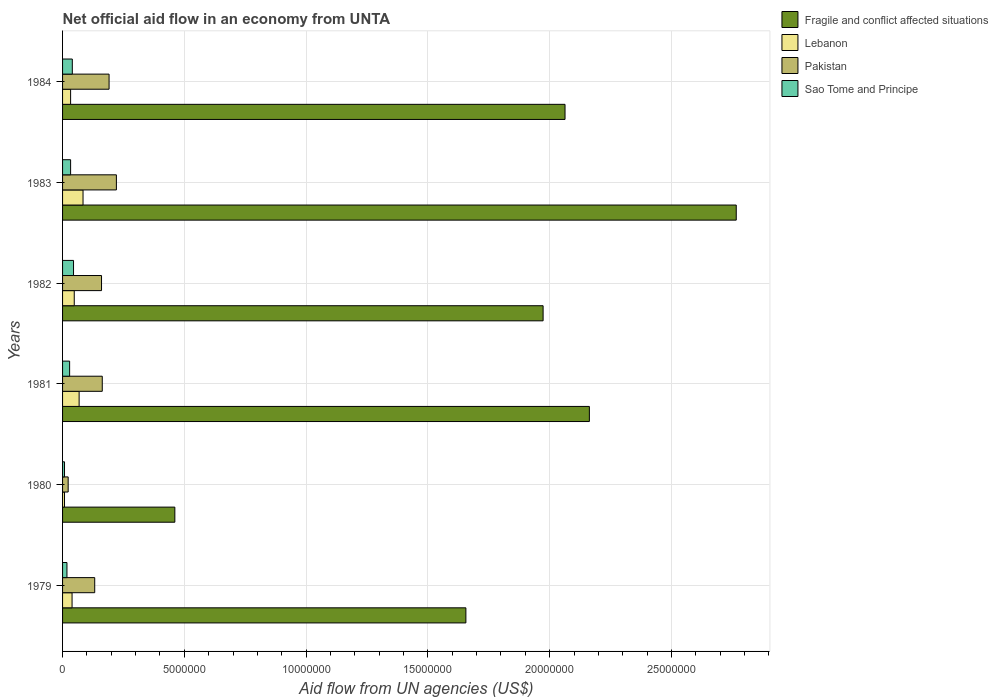How many different coloured bars are there?
Make the answer very short. 4. Are the number of bars on each tick of the Y-axis equal?
Your response must be concise. Yes. How many bars are there on the 5th tick from the bottom?
Make the answer very short. 4. In how many cases, is the number of bars for a given year not equal to the number of legend labels?
Give a very brief answer. 0. What is the net official aid flow in Fragile and conflict affected situations in 1980?
Make the answer very short. 4.61e+06. Across all years, what is the minimum net official aid flow in Lebanon?
Your response must be concise. 8.00e+04. In which year was the net official aid flow in Fragile and conflict affected situations minimum?
Ensure brevity in your answer.  1980. What is the total net official aid flow in Lebanon in the graph?
Your response must be concise. 2.80e+06. What is the difference between the net official aid flow in Fragile and conflict affected situations in 1979 and that in 1983?
Provide a succinct answer. -1.11e+07. What is the difference between the net official aid flow in Sao Tome and Principe in 1981 and the net official aid flow in Fragile and conflict affected situations in 1980?
Make the answer very short. -4.32e+06. What is the average net official aid flow in Pakistan per year?
Keep it short and to the point. 1.48e+06. In the year 1979, what is the difference between the net official aid flow in Sao Tome and Principe and net official aid flow in Pakistan?
Provide a succinct answer. -1.14e+06. In how many years, is the net official aid flow in Pakistan greater than 14000000 US$?
Give a very brief answer. 0. What is the ratio of the net official aid flow in Lebanon in 1981 to that in 1984?
Your answer should be compact. 2.06. What is the difference between the highest and the second highest net official aid flow in Sao Tome and Principe?
Give a very brief answer. 5.00e+04. What is the difference between the highest and the lowest net official aid flow in Pakistan?
Offer a terse response. 1.98e+06. Is it the case that in every year, the sum of the net official aid flow in Fragile and conflict affected situations and net official aid flow in Pakistan is greater than the sum of net official aid flow in Lebanon and net official aid flow in Sao Tome and Principe?
Provide a short and direct response. Yes. What does the 3rd bar from the top in 1983 represents?
Make the answer very short. Lebanon. What does the 1st bar from the bottom in 1979 represents?
Ensure brevity in your answer.  Fragile and conflict affected situations. How many years are there in the graph?
Provide a short and direct response. 6. Are the values on the major ticks of X-axis written in scientific E-notation?
Make the answer very short. No. Does the graph contain any zero values?
Offer a terse response. No. Does the graph contain grids?
Make the answer very short. Yes. Where does the legend appear in the graph?
Your response must be concise. Top right. How are the legend labels stacked?
Provide a succinct answer. Vertical. What is the title of the graph?
Your answer should be compact. Net official aid flow in an economy from UNTA. Does "Papua New Guinea" appear as one of the legend labels in the graph?
Give a very brief answer. No. What is the label or title of the X-axis?
Make the answer very short. Aid flow from UN agencies (US$). What is the Aid flow from UN agencies (US$) in Fragile and conflict affected situations in 1979?
Make the answer very short. 1.66e+07. What is the Aid flow from UN agencies (US$) of Lebanon in 1979?
Offer a very short reply. 3.90e+05. What is the Aid flow from UN agencies (US$) in Pakistan in 1979?
Ensure brevity in your answer.  1.32e+06. What is the Aid flow from UN agencies (US$) in Sao Tome and Principe in 1979?
Your response must be concise. 1.80e+05. What is the Aid flow from UN agencies (US$) in Fragile and conflict affected situations in 1980?
Your answer should be very brief. 4.61e+06. What is the Aid flow from UN agencies (US$) of Sao Tome and Principe in 1980?
Provide a short and direct response. 8.00e+04. What is the Aid flow from UN agencies (US$) of Fragile and conflict affected situations in 1981?
Offer a very short reply. 2.16e+07. What is the Aid flow from UN agencies (US$) in Lebanon in 1981?
Offer a very short reply. 6.80e+05. What is the Aid flow from UN agencies (US$) in Pakistan in 1981?
Provide a short and direct response. 1.63e+06. What is the Aid flow from UN agencies (US$) in Sao Tome and Principe in 1981?
Your answer should be compact. 2.90e+05. What is the Aid flow from UN agencies (US$) in Fragile and conflict affected situations in 1982?
Your answer should be compact. 1.97e+07. What is the Aid flow from UN agencies (US$) of Lebanon in 1982?
Offer a very short reply. 4.80e+05. What is the Aid flow from UN agencies (US$) of Pakistan in 1982?
Your answer should be very brief. 1.60e+06. What is the Aid flow from UN agencies (US$) of Fragile and conflict affected situations in 1983?
Give a very brief answer. 2.77e+07. What is the Aid flow from UN agencies (US$) of Lebanon in 1983?
Ensure brevity in your answer.  8.40e+05. What is the Aid flow from UN agencies (US$) in Pakistan in 1983?
Make the answer very short. 2.21e+06. What is the Aid flow from UN agencies (US$) in Sao Tome and Principe in 1983?
Your answer should be very brief. 3.30e+05. What is the Aid flow from UN agencies (US$) in Fragile and conflict affected situations in 1984?
Offer a very short reply. 2.06e+07. What is the Aid flow from UN agencies (US$) of Lebanon in 1984?
Your response must be concise. 3.30e+05. What is the Aid flow from UN agencies (US$) of Pakistan in 1984?
Give a very brief answer. 1.91e+06. What is the Aid flow from UN agencies (US$) in Sao Tome and Principe in 1984?
Offer a very short reply. 4.00e+05. Across all years, what is the maximum Aid flow from UN agencies (US$) of Fragile and conflict affected situations?
Provide a short and direct response. 2.77e+07. Across all years, what is the maximum Aid flow from UN agencies (US$) of Lebanon?
Provide a short and direct response. 8.40e+05. Across all years, what is the maximum Aid flow from UN agencies (US$) of Pakistan?
Offer a terse response. 2.21e+06. Across all years, what is the maximum Aid flow from UN agencies (US$) in Sao Tome and Principe?
Provide a short and direct response. 4.50e+05. Across all years, what is the minimum Aid flow from UN agencies (US$) in Fragile and conflict affected situations?
Offer a terse response. 4.61e+06. Across all years, what is the minimum Aid flow from UN agencies (US$) of Pakistan?
Offer a very short reply. 2.30e+05. What is the total Aid flow from UN agencies (US$) of Fragile and conflict affected situations in the graph?
Your response must be concise. 1.11e+08. What is the total Aid flow from UN agencies (US$) in Lebanon in the graph?
Ensure brevity in your answer.  2.80e+06. What is the total Aid flow from UN agencies (US$) in Pakistan in the graph?
Offer a terse response. 8.90e+06. What is the total Aid flow from UN agencies (US$) of Sao Tome and Principe in the graph?
Offer a very short reply. 1.73e+06. What is the difference between the Aid flow from UN agencies (US$) in Fragile and conflict affected situations in 1979 and that in 1980?
Ensure brevity in your answer.  1.20e+07. What is the difference between the Aid flow from UN agencies (US$) in Pakistan in 1979 and that in 1980?
Provide a short and direct response. 1.09e+06. What is the difference between the Aid flow from UN agencies (US$) of Fragile and conflict affected situations in 1979 and that in 1981?
Your answer should be compact. -5.07e+06. What is the difference between the Aid flow from UN agencies (US$) of Pakistan in 1979 and that in 1981?
Offer a terse response. -3.10e+05. What is the difference between the Aid flow from UN agencies (US$) of Fragile and conflict affected situations in 1979 and that in 1982?
Provide a succinct answer. -3.17e+06. What is the difference between the Aid flow from UN agencies (US$) of Pakistan in 1979 and that in 1982?
Provide a succinct answer. -2.80e+05. What is the difference between the Aid flow from UN agencies (US$) in Sao Tome and Principe in 1979 and that in 1982?
Your answer should be very brief. -2.70e+05. What is the difference between the Aid flow from UN agencies (US$) in Fragile and conflict affected situations in 1979 and that in 1983?
Provide a short and direct response. -1.11e+07. What is the difference between the Aid flow from UN agencies (US$) in Lebanon in 1979 and that in 1983?
Your response must be concise. -4.50e+05. What is the difference between the Aid flow from UN agencies (US$) in Pakistan in 1979 and that in 1983?
Your answer should be compact. -8.90e+05. What is the difference between the Aid flow from UN agencies (US$) of Fragile and conflict affected situations in 1979 and that in 1984?
Give a very brief answer. -4.07e+06. What is the difference between the Aid flow from UN agencies (US$) in Lebanon in 1979 and that in 1984?
Offer a very short reply. 6.00e+04. What is the difference between the Aid flow from UN agencies (US$) of Pakistan in 1979 and that in 1984?
Make the answer very short. -5.90e+05. What is the difference between the Aid flow from UN agencies (US$) of Fragile and conflict affected situations in 1980 and that in 1981?
Provide a short and direct response. -1.70e+07. What is the difference between the Aid flow from UN agencies (US$) in Lebanon in 1980 and that in 1981?
Give a very brief answer. -6.00e+05. What is the difference between the Aid flow from UN agencies (US$) in Pakistan in 1980 and that in 1981?
Offer a very short reply. -1.40e+06. What is the difference between the Aid flow from UN agencies (US$) in Fragile and conflict affected situations in 1980 and that in 1982?
Offer a very short reply. -1.51e+07. What is the difference between the Aid flow from UN agencies (US$) of Lebanon in 1980 and that in 1982?
Your answer should be compact. -4.00e+05. What is the difference between the Aid flow from UN agencies (US$) of Pakistan in 1980 and that in 1982?
Ensure brevity in your answer.  -1.37e+06. What is the difference between the Aid flow from UN agencies (US$) in Sao Tome and Principe in 1980 and that in 1982?
Your answer should be compact. -3.70e+05. What is the difference between the Aid flow from UN agencies (US$) of Fragile and conflict affected situations in 1980 and that in 1983?
Your answer should be very brief. -2.30e+07. What is the difference between the Aid flow from UN agencies (US$) in Lebanon in 1980 and that in 1983?
Offer a very short reply. -7.60e+05. What is the difference between the Aid flow from UN agencies (US$) in Pakistan in 1980 and that in 1983?
Keep it short and to the point. -1.98e+06. What is the difference between the Aid flow from UN agencies (US$) in Fragile and conflict affected situations in 1980 and that in 1984?
Provide a short and direct response. -1.60e+07. What is the difference between the Aid flow from UN agencies (US$) in Lebanon in 1980 and that in 1984?
Make the answer very short. -2.50e+05. What is the difference between the Aid flow from UN agencies (US$) in Pakistan in 1980 and that in 1984?
Provide a succinct answer. -1.68e+06. What is the difference between the Aid flow from UN agencies (US$) of Sao Tome and Principe in 1980 and that in 1984?
Offer a very short reply. -3.20e+05. What is the difference between the Aid flow from UN agencies (US$) of Fragile and conflict affected situations in 1981 and that in 1982?
Keep it short and to the point. 1.90e+06. What is the difference between the Aid flow from UN agencies (US$) in Pakistan in 1981 and that in 1982?
Offer a very short reply. 3.00e+04. What is the difference between the Aid flow from UN agencies (US$) of Sao Tome and Principe in 1981 and that in 1982?
Your response must be concise. -1.60e+05. What is the difference between the Aid flow from UN agencies (US$) of Fragile and conflict affected situations in 1981 and that in 1983?
Give a very brief answer. -6.03e+06. What is the difference between the Aid flow from UN agencies (US$) in Pakistan in 1981 and that in 1983?
Your answer should be compact. -5.80e+05. What is the difference between the Aid flow from UN agencies (US$) in Sao Tome and Principe in 1981 and that in 1983?
Your response must be concise. -4.00e+04. What is the difference between the Aid flow from UN agencies (US$) of Fragile and conflict affected situations in 1981 and that in 1984?
Your response must be concise. 1.00e+06. What is the difference between the Aid flow from UN agencies (US$) of Lebanon in 1981 and that in 1984?
Your answer should be very brief. 3.50e+05. What is the difference between the Aid flow from UN agencies (US$) of Pakistan in 1981 and that in 1984?
Offer a terse response. -2.80e+05. What is the difference between the Aid flow from UN agencies (US$) of Fragile and conflict affected situations in 1982 and that in 1983?
Provide a short and direct response. -7.93e+06. What is the difference between the Aid flow from UN agencies (US$) of Lebanon in 1982 and that in 1983?
Provide a short and direct response. -3.60e+05. What is the difference between the Aid flow from UN agencies (US$) in Pakistan in 1982 and that in 1983?
Offer a very short reply. -6.10e+05. What is the difference between the Aid flow from UN agencies (US$) in Sao Tome and Principe in 1982 and that in 1983?
Provide a succinct answer. 1.20e+05. What is the difference between the Aid flow from UN agencies (US$) in Fragile and conflict affected situations in 1982 and that in 1984?
Your answer should be very brief. -9.00e+05. What is the difference between the Aid flow from UN agencies (US$) in Pakistan in 1982 and that in 1984?
Your answer should be compact. -3.10e+05. What is the difference between the Aid flow from UN agencies (US$) in Fragile and conflict affected situations in 1983 and that in 1984?
Your response must be concise. 7.03e+06. What is the difference between the Aid flow from UN agencies (US$) in Lebanon in 1983 and that in 1984?
Your response must be concise. 5.10e+05. What is the difference between the Aid flow from UN agencies (US$) in Fragile and conflict affected situations in 1979 and the Aid flow from UN agencies (US$) in Lebanon in 1980?
Your response must be concise. 1.65e+07. What is the difference between the Aid flow from UN agencies (US$) in Fragile and conflict affected situations in 1979 and the Aid flow from UN agencies (US$) in Pakistan in 1980?
Offer a terse response. 1.63e+07. What is the difference between the Aid flow from UN agencies (US$) in Fragile and conflict affected situations in 1979 and the Aid flow from UN agencies (US$) in Sao Tome and Principe in 1980?
Ensure brevity in your answer.  1.65e+07. What is the difference between the Aid flow from UN agencies (US$) of Lebanon in 1979 and the Aid flow from UN agencies (US$) of Pakistan in 1980?
Ensure brevity in your answer.  1.60e+05. What is the difference between the Aid flow from UN agencies (US$) of Lebanon in 1979 and the Aid flow from UN agencies (US$) of Sao Tome and Principe in 1980?
Make the answer very short. 3.10e+05. What is the difference between the Aid flow from UN agencies (US$) in Pakistan in 1979 and the Aid flow from UN agencies (US$) in Sao Tome and Principe in 1980?
Provide a succinct answer. 1.24e+06. What is the difference between the Aid flow from UN agencies (US$) of Fragile and conflict affected situations in 1979 and the Aid flow from UN agencies (US$) of Lebanon in 1981?
Offer a terse response. 1.59e+07. What is the difference between the Aid flow from UN agencies (US$) in Fragile and conflict affected situations in 1979 and the Aid flow from UN agencies (US$) in Pakistan in 1981?
Ensure brevity in your answer.  1.49e+07. What is the difference between the Aid flow from UN agencies (US$) in Fragile and conflict affected situations in 1979 and the Aid flow from UN agencies (US$) in Sao Tome and Principe in 1981?
Keep it short and to the point. 1.63e+07. What is the difference between the Aid flow from UN agencies (US$) in Lebanon in 1979 and the Aid flow from UN agencies (US$) in Pakistan in 1981?
Make the answer very short. -1.24e+06. What is the difference between the Aid flow from UN agencies (US$) of Pakistan in 1979 and the Aid flow from UN agencies (US$) of Sao Tome and Principe in 1981?
Provide a short and direct response. 1.03e+06. What is the difference between the Aid flow from UN agencies (US$) in Fragile and conflict affected situations in 1979 and the Aid flow from UN agencies (US$) in Lebanon in 1982?
Offer a terse response. 1.61e+07. What is the difference between the Aid flow from UN agencies (US$) in Fragile and conflict affected situations in 1979 and the Aid flow from UN agencies (US$) in Pakistan in 1982?
Offer a terse response. 1.50e+07. What is the difference between the Aid flow from UN agencies (US$) of Fragile and conflict affected situations in 1979 and the Aid flow from UN agencies (US$) of Sao Tome and Principe in 1982?
Your answer should be very brief. 1.61e+07. What is the difference between the Aid flow from UN agencies (US$) of Lebanon in 1979 and the Aid flow from UN agencies (US$) of Pakistan in 1982?
Your answer should be compact. -1.21e+06. What is the difference between the Aid flow from UN agencies (US$) in Lebanon in 1979 and the Aid flow from UN agencies (US$) in Sao Tome and Principe in 1982?
Ensure brevity in your answer.  -6.00e+04. What is the difference between the Aid flow from UN agencies (US$) in Pakistan in 1979 and the Aid flow from UN agencies (US$) in Sao Tome and Principe in 1982?
Ensure brevity in your answer.  8.70e+05. What is the difference between the Aid flow from UN agencies (US$) of Fragile and conflict affected situations in 1979 and the Aid flow from UN agencies (US$) of Lebanon in 1983?
Your answer should be compact. 1.57e+07. What is the difference between the Aid flow from UN agencies (US$) in Fragile and conflict affected situations in 1979 and the Aid flow from UN agencies (US$) in Pakistan in 1983?
Make the answer very short. 1.44e+07. What is the difference between the Aid flow from UN agencies (US$) of Fragile and conflict affected situations in 1979 and the Aid flow from UN agencies (US$) of Sao Tome and Principe in 1983?
Provide a short and direct response. 1.62e+07. What is the difference between the Aid flow from UN agencies (US$) in Lebanon in 1979 and the Aid flow from UN agencies (US$) in Pakistan in 1983?
Your answer should be compact. -1.82e+06. What is the difference between the Aid flow from UN agencies (US$) of Pakistan in 1979 and the Aid flow from UN agencies (US$) of Sao Tome and Principe in 1983?
Your response must be concise. 9.90e+05. What is the difference between the Aid flow from UN agencies (US$) in Fragile and conflict affected situations in 1979 and the Aid flow from UN agencies (US$) in Lebanon in 1984?
Provide a succinct answer. 1.62e+07. What is the difference between the Aid flow from UN agencies (US$) of Fragile and conflict affected situations in 1979 and the Aid flow from UN agencies (US$) of Pakistan in 1984?
Give a very brief answer. 1.46e+07. What is the difference between the Aid flow from UN agencies (US$) in Fragile and conflict affected situations in 1979 and the Aid flow from UN agencies (US$) in Sao Tome and Principe in 1984?
Your response must be concise. 1.62e+07. What is the difference between the Aid flow from UN agencies (US$) of Lebanon in 1979 and the Aid flow from UN agencies (US$) of Pakistan in 1984?
Make the answer very short. -1.52e+06. What is the difference between the Aid flow from UN agencies (US$) in Pakistan in 1979 and the Aid flow from UN agencies (US$) in Sao Tome and Principe in 1984?
Make the answer very short. 9.20e+05. What is the difference between the Aid flow from UN agencies (US$) in Fragile and conflict affected situations in 1980 and the Aid flow from UN agencies (US$) in Lebanon in 1981?
Make the answer very short. 3.93e+06. What is the difference between the Aid flow from UN agencies (US$) of Fragile and conflict affected situations in 1980 and the Aid flow from UN agencies (US$) of Pakistan in 1981?
Make the answer very short. 2.98e+06. What is the difference between the Aid flow from UN agencies (US$) in Fragile and conflict affected situations in 1980 and the Aid flow from UN agencies (US$) in Sao Tome and Principe in 1981?
Give a very brief answer. 4.32e+06. What is the difference between the Aid flow from UN agencies (US$) of Lebanon in 1980 and the Aid flow from UN agencies (US$) of Pakistan in 1981?
Your response must be concise. -1.55e+06. What is the difference between the Aid flow from UN agencies (US$) of Lebanon in 1980 and the Aid flow from UN agencies (US$) of Sao Tome and Principe in 1981?
Provide a succinct answer. -2.10e+05. What is the difference between the Aid flow from UN agencies (US$) of Fragile and conflict affected situations in 1980 and the Aid flow from UN agencies (US$) of Lebanon in 1982?
Keep it short and to the point. 4.13e+06. What is the difference between the Aid flow from UN agencies (US$) of Fragile and conflict affected situations in 1980 and the Aid flow from UN agencies (US$) of Pakistan in 1982?
Ensure brevity in your answer.  3.01e+06. What is the difference between the Aid flow from UN agencies (US$) of Fragile and conflict affected situations in 1980 and the Aid flow from UN agencies (US$) of Sao Tome and Principe in 1982?
Your answer should be very brief. 4.16e+06. What is the difference between the Aid flow from UN agencies (US$) in Lebanon in 1980 and the Aid flow from UN agencies (US$) in Pakistan in 1982?
Keep it short and to the point. -1.52e+06. What is the difference between the Aid flow from UN agencies (US$) in Lebanon in 1980 and the Aid flow from UN agencies (US$) in Sao Tome and Principe in 1982?
Your answer should be compact. -3.70e+05. What is the difference between the Aid flow from UN agencies (US$) in Pakistan in 1980 and the Aid flow from UN agencies (US$) in Sao Tome and Principe in 1982?
Provide a short and direct response. -2.20e+05. What is the difference between the Aid flow from UN agencies (US$) in Fragile and conflict affected situations in 1980 and the Aid flow from UN agencies (US$) in Lebanon in 1983?
Ensure brevity in your answer.  3.77e+06. What is the difference between the Aid flow from UN agencies (US$) in Fragile and conflict affected situations in 1980 and the Aid flow from UN agencies (US$) in Pakistan in 1983?
Your answer should be compact. 2.40e+06. What is the difference between the Aid flow from UN agencies (US$) of Fragile and conflict affected situations in 1980 and the Aid flow from UN agencies (US$) of Sao Tome and Principe in 1983?
Give a very brief answer. 4.28e+06. What is the difference between the Aid flow from UN agencies (US$) of Lebanon in 1980 and the Aid flow from UN agencies (US$) of Pakistan in 1983?
Your response must be concise. -2.13e+06. What is the difference between the Aid flow from UN agencies (US$) of Pakistan in 1980 and the Aid flow from UN agencies (US$) of Sao Tome and Principe in 1983?
Provide a succinct answer. -1.00e+05. What is the difference between the Aid flow from UN agencies (US$) of Fragile and conflict affected situations in 1980 and the Aid flow from UN agencies (US$) of Lebanon in 1984?
Give a very brief answer. 4.28e+06. What is the difference between the Aid flow from UN agencies (US$) of Fragile and conflict affected situations in 1980 and the Aid flow from UN agencies (US$) of Pakistan in 1984?
Provide a short and direct response. 2.70e+06. What is the difference between the Aid flow from UN agencies (US$) of Fragile and conflict affected situations in 1980 and the Aid flow from UN agencies (US$) of Sao Tome and Principe in 1984?
Your response must be concise. 4.21e+06. What is the difference between the Aid flow from UN agencies (US$) of Lebanon in 1980 and the Aid flow from UN agencies (US$) of Pakistan in 1984?
Ensure brevity in your answer.  -1.83e+06. What is the difference between the Aid flow from UN agencies (US$) of Lebanon in 1980 and the Aid flow from UN agencies (US$) of Sao Tome and Principe in 1984?
Keep it short and to the point. -3.20e+05. What is the difference between the Aid flow from UN agencies (US$) of Pakistan in 1980 and the Aid flow from UN agencies (US$) of Sao Tome and Principe in 1984?
Your response must be concise. -1.70e+05. What is the difference between the Aid flow from UN agencies (US$) of Fragile and conflict affected situations in 1981 and the Aid flow from UN agencies (US$) of Lebanon in 1982?
Your response must be concise. 2.12e+07. What is the difference between the Aid flow from UN agencies (US$) in Fragile and conflict affected situations in 1981 and the Aid flow from UN agencies (US$) in Pakistan in 1982?
Provide a succinct answer. 2.00e+07. What is the difference between the Aid flow from UN agencies (US$) of Fragile and conflict affected situations in 1981 and the Aid flow from UN agencies (US$) of Sao Tome and Principe in 1982?
Provide a succinct answer. 2.12e+07. What is the difference between the Aid flow from UN agencies (US$) of Lebanon in 1981 and the Aid flow from UN agencies (US$) of Pakistan in 1982?
Ensure brevity in your answer.  -9.20e+05. What is the difference between the Aid flow from UN agencies (US$) of Lebanon in 1981 and the Aid flow from UN agencies (US$) of Sao Tome and Principe in 1982?
Offer a very short reply. 2.30e+05. What is the difference between the Aid flow from UN agencies (US$) of Pakistan in 1981 and the Aid flow from UN agencies (US$) of Sao Tome and Principe in 1982?
Keep it short and to the point. 1.18e+06. What is the difference between the Aid flow from UN agencies (US$) of Fragile and conflict affected situations in 1981 and the Aid flow from UN agencies (US$) of Lebanon in 1983?
Provide a short and direct response. 2.08e+07. What is the difference between the Aid flow from UN agencies (US$) in Fragile and conflict affected situations in 1981 and the Aid flow from UN agencies (US$) in Pakistan in 1983?
Your answer should be very brief. 1.94e+07. What is the difference between the Aid flow from UN agencies (US$) in Fragile and conflict affected situations in 1981 and the Aid flow from UN agencies (US$) in Sao Tome and Principe in 1983?
Offer a very short reply. 2.13e+07. What is the difference between the Aid flow from UN agencies (US$) of Lebanon in 1981 and the Aid flow from UN agencies (US$) of Pakistan in 1983?
Provide a short and direct response. -1.53e+06. What is the difference between the Aid flow from UN agencies (US$) in Pakistan in 1981 and the Aid flow from UN agencies (US$) in Sao Tome and Principe in 1983?
Your answer should be very brief. 1.30e+06. What is the difference between the Aid flow from UN agencies (US$) in Fragile and conflict affected situations in 1981 and the Aid flow from UN agencies (US$) in Lebanon in 1984?
Ensure brevity in your answer.  2.13e+07. What is the difference between the Aid flow from UN agencies (US$) of Fragile and conflict affected situations in 1981 and the Aid flow from UN agencies (US$) of Pakistan in 1984?
Your answer should be very brief. 1.97e+07. What is the difference between the Aid flow from UN agencies (US$) of Fragile and conflict affected situations in 1981 and the Aid flow from UN agencies (US$) of Sao Tome and Principe in 1984?
Keep it short and to the point. 2.12e+07. What is the difference between the Aid flow from UN agencies (US$) of Lebanon in 1981 and the Aid flow from UN agencies (US$) of Pakistan in 1984?
Ensure brevity in your answer.  -1.23e+06. What is the difference between the Aid flow from UN agencies (US$) in Lebanon in 1981 and the Aid flow from UN agencies (US$) in Sao Tome and Principe in 1984?
Provide a short and direct response. 2.80e+05. What is the difference between the Aid flow from UN agencies (US$) of Pakistan in 1981 and the Aid flow from UN agencies (US$) of Sao Tome and Principe in 1984?
Your answer should be compact. 1.23e+06. What is the difference between the Aid flow from UN agencies (US$) in Fragile and conflict affected situations in 1982 and the Aid flow from UN agencies (US$) in Lebanon in 1983?
Make the answer very short. 1.89e+07. What is the difference between the Aid flow from UN agencies (US$) in Fragile and conflict affected situations in 1982 and the Aid flow from UN agencies (US$) in Pakistan in 1983?
Offer a very short reply. 1.75e+07. What is the difference between the Aid flow from UN agencies (US$) in Fragile and conflict affected situations in 1982 and the Aid flow from UN agencies (US$) in Sao Tome and Principe in 1983?
Your answer should be compact. 1.94e+07. What is the difference between the Aid flow from UN agencies (US$) in Lebanon in 1982 and the Aid flow from UN agencies (US$) in Pakistan in 1983?
Your response must be concise. -1.73e+06. What is the difference between the Aid flow from UN agencies (US$) of Lebanon in 1982 and the Aid flow from UN agencies (US$) of Sao Tome and Principe in 1983?
Give a very brief answer. 1.50e+05. What is the difference between the Aid flow from UN agencies (US$) in Pakistan in 1982 and the Aid flow from UN agencies (US$) in Sao Tome and Principe in 1983?
Offer a very short reply. 1.27e+06. What is the difference between the Aid flow from UN agencies (US$) in Fragile and conflict affected situations in 1982 and the Aid flow from UN agencies (US$) in Lebanon in 1984?
Provide a short and direct response. 1.94e+07. What is the difference between the Aid flow from UN agencies (US$) in Fragile and conflict affected situations in 1982 and the Aid flow from UN agencies (US$) in Pakistan in 1984?
Your answer should be compact. 1.78e+07. What is the difference between the Aid flow from UN agencies (US$) of Fragile and conflict affected situations in 1982 and the Aid flow from UN agencies (US$) of Sao Tome and Principe in 1984?
Your response must be concise. 1.93e+07. What is the difference between the Aid flow from UN agencies (US$) of Lebanon in 1982 and the Aid flow from UN agencies (US$) of Pakistan in 1984?
Your answer should be very brief. -1.43e+06. What is the difference between the Aid flow from UN agencies (US$) of Pakistan in 1982 and the Aid flow from UN agencies (US$) of Sao Tome and Principe in 1984?
Make the answer very short. 1.20e+06. What is the difference between the Aid flow from UN agencies (US$) of Fragile and conflict affected situations in 1983 and the Aid flow from UN agencies (US$) of Lebanon in 1984?
Your response must be concise. 2.73e+07. What is the difference between the Aid flow from UN agencies (US$) of Fragile and conflict affected situations in 1983 and the Aid flow from UN agencies (US$) of Pakistan in 1984?
Your answer should be very brief. 2.58e+07. What is the difference between the Aid flow from UN agencies (US$) of Fragile and conflict affected situations in 1983 and the Aid flow from UN agencies (US$) of Sao Tome and Principe in 1984?
Ensure brevity in your answer.  2.73e+07. What is the difference between the Aid flow from UN agencies (US$) of Lebanon in 1983 and the Aid flow from UN agencies (US$) of Pakistan in 1984?
Your answer should be compact. -1.07e+06. What is the difference between the Aid flow from UN agencies (US$) of Pakistan in 1983 and the Aid flow from UN agencies (US$) of Sao Tome and Principe in 1984?
Provide a short and direct response. 1.81e+06. What is the average Aid flow from UN agencies (US$) in Fragile and conflict affected situations per year?
Your answer should be very brief. 1.85e+07. What is the average Aid flow from UN agencies (US$) of Lebanon per year?
Keep it short and to the point. 4.67e+05. What is the average Aid flow from UN agencies (US$) in Pakistan per year?
Give a very brief answer. 1.48e+06. What is the average Aid flow from UN agencies (US$) of Sao Tome and Principe per year?
Keep it short and to the point. 2.88e+05. In the year 1979, what is the difference between the Aid flow from UN agencies (US$) in Fragile and conflict affected situations and Aid flow from UN agencies (US$) in Lebanon?
Give a very brief answer. 1.62e+07. In the year 1979, what is the difference between the Aid flow from UN agencies (US$) of Fragile and conflict affected situations and Aid flow from UN agencies (US$) of Pakistan?
Offer a very short reply. 1.52e+07. In the year 1979, what is the difference between the Aid flow from UN agencies (US$) in Fragile and conflict affected situations and Aid flow from UN agencies (US$) in Sao Tome and Principe?
Your response must be concise. 1.64e+07. In the year 1979, what is the difference between the Aid flow from UN agencies (US$) of Lebanon and Aid flow from UN agencies (US$) of Pakistan?
Provide a succinct answer. -9.30e+05. In the year 1979, what is the difference between the Aid flow from UN agencies (US$) of Pakistan and Aid flow from UN agencies (US$) of Sao Tome and Principe?
Ensure brevity in your answer.  1.14e+06. In the year 1980, what is the difference between the Aid flow from UN agencies (US$) in Fragile and conflict affected situations and Aid flow from UN agencies (US$) in Lebanon?
Your answer should be very brief. 4.53e+06. In the year 1980, what is the difference between the Aid flow from UN agencies (US$) of Fragile and conflict affected situations and Aid flow from UN agencies (US$) of Pakistan?
Offer a very short reply. 4.38e+06. In the year 1980, what is the difference between the Aid flow from UN agencies (US$) in Fragile and conflict affected situations and Aid flow from UN agencies (US$) in Sao Tome and Principe?
Your answer should be very brief. 4.53e+06. In the year 1980, what is the difference between the Aid flow from UN agencies (US$) of Lebanon and Aid flow from UN agencies (US$) of Pakistan?
Offer a terse response. -1.50e+05. In the year 1980, what is the difference between the Aid flow from UN agencies (US$) of Lebanon and Aid flow from UN agencies (US$) of Sao Tome and Principe?
Your answer should be compact. 0. In the year 1980, what is the difference between the Aid flow from UN agencies (US$) of Pakistan and Aid flow from UN agencies (US$) of Sao Tome and Principe?
Offer a very short reply. 1.50e+05. In the year 1981, what is the difference between the Aid flow from UN agencies (US$) in Fragile and conflict affected situations and Aid flow from UN agencies (US$) in Lebanon?
Offer a very short reply. 2.10e+07. In the year 1981, what is the difference between the Aid flow from UN agencies (US$) in Fragile and conflict affected situations and Aid flow from UN agencies (US$) in Sao Tome and Principe?
Make the answer very short. 2.13e+07. In the year 1981, what is the difference between the Aid flow from UN agencies (US$) in Lebanon and Aid flow from UN agencies (US$) in Pakistan?
Offer a very short reply. -9.50e+05. In the year 1981, what is the difference between the Aid flow from UN agencies (US$) of Lebanon and Aid flow from UN agencies (US$) of Sao Tome and Principe?
Your answer should be compact. 3.90e+05. In the year 1981, what is the difference between the Aid flow from UN agencies (US$) of Pakistan and Aid flow from UN agencies (US$) of Sao Tome and Principe?
Your answer should be very brief. 1.34e+06. In the year 1982, what is the difference between the Aid flow from UN agencies (US$) in Fragile and conflict affected situations and Aid flow from UN agencies (US$) in Lebanon?
Make the answer very short. 1.92e+07. In the year 1982, what is the difference between the Aid flow from UN agencies (US$) of Fragile and conflict affected situations and Aid flow from UN agencies (US$) of Pakistan?
Give a very brief answer. 1.81e+07. In the year 1982, what is the difference between the Aid flow from UN agencies (US$) of Fragile and conflict affected situations and Aid flow from UN agencies (US$) of Sao Tome and Principe?
Provide a succinct answer. 1.93e+07. In the year 1982, what is the difference between the Aid flow from UN agencies (US$) in Lebanon and Aid flow from UN agencies (US$) in Pakistan?
Your answer should be compact. -1.12e+06. In the year 1982, what is the difference between the Aid flow from UN agencies (US$) of Lebanon and Aid flow from UN agencies (US$) of Sao Tome and Principe?
Give a very brief answer. 3.00e+04. In the year 1982, what is the difference between the Aid flow from UN agencies (US$) in Pakistan and Aid flow from UN agencies (US$) in Sao Tome and Principe?
Provide a short and direct response. 1.15e+06. In the year 1983, what is the difference between the Aid flow from UN agencies (US$) of Fragile and conflict affected situations and Aid flow from UN agencies (US$) of Lebanon?
Your answer should be very brief. 2.68e+07. In the year 1983, what is the difference between the Aid flow from UN agencies (US$) in Fragile and conflict affected situations and Aid flow from UN agencies (US$) in Pakistan?
Ensure brevity in your answer.  2.54e+07. In the year 1983, what is the difference between the Aid flow from UN agencies (US$) in Fragile and conflict affected situations and Aid flow from UN agencies (US$) in Sao Tome and Principe?
Your answer should be compact. 2.73e+07. In the year 1983, what is the difference between the Aid flow from UN agencies (US$) of Lebanon and Aid flow from UN agencies (US$) of Pakistan?
Your response must be concise. -1.37e+06. In the year 1983, what is the difference between the Aid flow from UN agencies (US$) of Lebanon and Aid flow from UN agencies (US$) of Sao Tome and Principe?
Your response must be concise. 5.10e+05. In the year 1983, what is the difference between the Aid flow from UN agencies (US$) in Pakistan and Aid flow from UN agencies (US$) in Sao Tome and Principe?
Your answer should be compact. 1.88e+06. In the year 1984, what is the difference between the Aid flow from UN agencies (US$) of Fragile and conflict affected situations and Aid flow from UN agencies (US$) of Lebanon?
Your response must be concise. 2.03e+07. In the year 1984, what is the difference between the Aid flow from UN agencies (US$) of Fragile and conflict affected situations and Aid flow from UN agencies (US$) of Pakistan?
Offer a very short reply. 1.87e+07. In the year 1984, what is the difference between the Aid flow from UN agencies (US$) in Fragile and conflict affected situations and Aid flow from UN agencies (US$) in Sao Tome and Principe?
Your answer should be very brief. 2.02e+07. In the year 1984, what is the difference between the Aid flow from UN agencies (US$) in Lebanon and Aid flow from UN agencies (US$) in Pakistan?
Provide a succinct answer. -1.58e+06. In the year 1984, what is the difference between the Aid flow from UN agencies (US$) of Lebanon and Aid flow from UN agencies (US$) of Sao Tome and Principe?
Offer a very short reply. -7.00e+04. In the year 1984, what is the difference between the Aid flow from UN agencies (US$) of Pakistan and Aid flow from UN agencies (US$) of Sao Tome and Principe?
Your answer should be very brief. 1.51e+06. What is the ratio of the Aid flow from UN agencies (US$) in Fragile and conflict affected situations in 1979 to that in 1980?
Provide a short and direct response. 3.59. What is the ratio of the Aid flow from UN agencies (US$) of Lebanon in 1979 to that in 1980?
Ensure brevity in your answer.  4.88. What is the ratio of the Aid flow from UN agencies (US$) in Pakistan in 1979 to that in 1980?
Your answer should be very brief. 5.74. What is the ratio of the Aid flow from UN agencies (US$) in Sao Tome and Principe in 1979 to that in 1980?
Keep it short and to the point. 2.25. What is the ratio of the Aid flow from UN agencies (US$) in Fragile and conflict affected situations in 1979 to that in 1981?
Provide a succinct answer. 0.77. What is the ratio of the Aid flow from UN agencies (US$) of Lebanon in 1979 to that in 1981?
Offer a very short reply. 0.57. What is the ratio of the Aid flow from UN agencies (US$) in Pakistan in 1979 to that in 1981?
Make the answer very short. 0.81. What is the ratio of the Aid flow from UN agencies (US$) in Sao Tome and Principe in 1979 to that in 1981?
Keep it short and to the point. 0.62. What is the ratio of the Aid flow from UN agencies (US$) of Fragile and conflict affected situations in 1979 to that in 1982?
Your response must be concise. 0.84. What is the ratio of the Aid flow from UN agencies (US$) in Lebanon in 1979 to that in 1982?
Provide a succinct answer. 0.81. What is the ratio of the Aid flow from UN agencies (US$) of Pakistan in 1979 to that in 1982?
Provide a succinct answer. 0.82. What is the ratio of the Aid flow from UN agencies (US$) of Fragile and conflict affected situations in 1979 to that in 1983?
Provide a succinct answer. 0.6. What is the ratio of the Aid flow from UN agencies (US$) of Lebanon in 1979 to that in 1983?
Give a very brief answer. 0.46. What is the ratio of the Aid flow from UN agencies (US$) of Pakistan in 1979 to that in 1983?
Your answer should be very brief. 0.6. What is the ratio of the Aid flow from UN agencies (US$) in Sao Tome and Principe in 1979 to that in 1983?
Ensure brevity in your answer.  0.55. What is the ratio of the Aid flow from UN agencies (US$) of Fragile and conflict affected situations in 1979 to that in 1984?
Make the answer very short. 0.8. What is the ratio of the Aid flow from UN agencies (US$) of Lebanon in 1979 to that in 1984?
Keep it short and to the point. 1.18. What is the ratio of the Aid flow from UN agencies (US$) of Pakistan in 1979 to that in 1984?
Your answer should be very brief. 0.69. What is the ratio of the Aid flow from UN agencies (US$) in Sao Tome and Principe in 1979 to that in 1984?
Provide a short and direct response. 0.45. What is the ratio of the Aid flow from UN agencies (US$) in Fragile and conflict affected situations in 1980 to that in 1981?
Your answer should be very brief. 0.21. What is the ratio of the Aid flow from UN agencies (US$) of Lebanon in 1980 to that in 1981?
Offer a very short reply. 0.12. What is the ratio of the Aid flow from UN agencies (US$) in Pakistan in 1980 to that in 1981?
Ensure brevity in your answer.  0.14. What is the ratio of the Aid flow from UN agencies (US$) of Sao Tome and Principe in 1980 to that in 1981?
Make the answer very short. 0.28. What is the ratio of the Aid flow from UN agencies (US$) in Fragile and conflict affected situations in 1980 to that in 1982?
Your answer should be very brief. 0.23. What is the ratio of the Aid flow from UN agencies (US$) in Lebanon in 1980 to that in 1982?
Provide a short and direct response. 0.17. What is the ratio of the Aid flow from UN agencies (US$) in Pakistan in 1980 to that in 1982?
Provide a short and direct response. 0.14. What is the ratio of the Aid flow from UN agencies (US$) of Sao Tome and Principe in 1980 to that in 1982?
Offer a very short reply. 0.18. What is the ratio of the Aid flow from UN agencies (US$) of Fragile and conflict affected situations in 1980 to that in 1983?
Offer a terse response. 0.17. What is the ratio of the Aid flow from UN agencies (US$) in Lebanon in 1980 to that in 1983?
Your response must be concise. 0.1. What is the ratio of the Aid flow from UN agencies (US$) in Pakistan in 1980 to that in 1983?
Give a very brief answer. 0.1. What is the ratio of the Aid flow from UN agencies (US$) of Sao Tome and Principe in 1980 to that in 1983?
Make the answer very short. 0.24. What is the ratio of the Aid flow from UN agencies (US$) of Fragile and conflict affected situations in 1980 to that in 1984?
Offer a very short reply. 0.22. What is the ratio of the Aid flow from UN agencies (US$) in Lebanon in 1980 to that in 1984?
Provide a succinct answer. 0.24. What is the ratio of the Aid flow from UN agencies (US$) of Pakistan in 1980 to that in 1984?
Provide a short and direct response. 0.12. What is the ratio of the Aid flow from UN agencies (US$) of Sao Tome and Principe in 1980 to that in 1984?
Provide a short and direct response. 0.2. What is the ratio of the Aid flow from UN agencies (US$) of Fragile and conflict affected situations in 1981 to that in 1982?
Provide a short and direct response. 1.1. What is the ratio of the Aid flow from UN agencies (US$) in Lebanon in 1981 to that in 1982?
Provide a succinct answer. 1.42. What is the ratio of the Aid flow from UN agencies (US$) in Pakistan in 1981 to that in 1982?
Provide a succinct answer. 1.02. What is the ratio of the Aid flow from UN agencies (US$) in Sao Tome and Principe in 1981 to that in 1982?
Keep it short and to the point. 0.64. What is the ratio of the Aid flow from UN agencies (US$) in Fragile and conflict affected situations in 1981 to that in 1983?
Keep it short and to the point. 0.78. What is the ratio of the Aid flow from UN agencies (US$) of Lebanon in 1981 to that in 1983?
Give a very brief answer. 0.81. What is the ratio of the Aid flow from UN agencies (US$) in Pakistan in 1981 to that in 1983?
Provide a short and direct response. 0.74. What is the ratio of the Aid flow from UN agencies (US$) in Sao Tome and Principe in 1981 to that in 1983?
Offer a very short reply. 0.88. What is the ratio of the Aid flow from UN agencies (US$) in Fragile and conflict affected situations in 1981 to that in 1984?
Give a very brief answer. 1.05. What is the ratio of the Aid flow from UN agencies (US$) in Lebanon in 1981 to that in 1984?
Your answer should be compact. 2.06. What is the ratio of the Aid flow from UN agencies (US$) in Pakistan in 1981 to that in 1984?
Offer a very short reply. 0.85. What is the ratio of the Aid flow from UN agencies (US$) in Sao Tome and Principe in 1981 to that in 1984?
Offer a very short reply. 0.72. What is the ratio of the Aid flow from UN agencies (US$) in Fragile and conflict affected situations in 1982 to that in 1983?
Your answer should be very brief. 0.71. What is the ratio of the Aid flow from UN agencies (US$) in Pakistan in 1982 to that in 1983?
Ensure brevity in your answer.  0.72. What is the ratio of the Aid flow from UN agencies (US$) of Sao Tome and Principe in 1982 to that in 1983?
Provide a short and direct response. 1.36. What is the ratio of the Aid flow from UN agencies (US$) in Fragile and conflict affected situations in 1982 to that in 1984?
Your response must be concise. 0.96. What is the ratio of the Aid flow from UN agencies (US$) in Lebanon in 1982 to that in 1984?
Your answer should be very brief. 1.45. What is the ratio of the Aid flow from UN agencies (US$) in Pakistan in 1982 to that in 1984?
Give a very brief answer. 0.84. What is the ratio of the Aid flow from UN agencies (US$) of Sao Tome and Principe in 1982 to that in 1984?
Keep it short and to the point. 1.12. What is the ratio of the Aid flow from UN agencies (US$) of Fragile and conflict affected situations in 1983 to that in 1984?
Give a very brief answer. 1.34. What is the ratio of the Aid flow from UN agencies (US$) of Lebanon in 1983 to that in 1984?
Provide a short and direct response. 2.55. What is the ratio of the Aid flow from UN agencies (US$) in Pakistan in 1983 to that in 1984?
Provide a short and direct response. 1.16. What is the ratio of the Aid flow from UN agencies (US$) of Sao Tome and Principe in 1983 to that in 1984?
Keep it short and to the point. 0.82. What is the difference between the highest and the second highest Aid flow from UN agencies (US$) of Fragile and conflict affected situations?
Provide a short and direct response. 6.03e+06. What is the difference between the highest and the second highest Aid flow from UN agencies (US$) of Lebanon?
Your answer should be compact. 1.60e+05. What is the difference between the highest and the second highest Aid flow from UN agencies (US$) of Pakistan?
Ensure brevity in your answer.  3.00e+05. What is the difference between the highest and the second highest Aid flow from UN agencies (US$) in Sao Tome and Principe?
Make the answer very short. 5.00e+04. What is the difference between the highest and the lowest Aid flow from UN agencies (US$) of Fragile and conflict affected situations?
Ensure brevity in your answer.  2.30e+07. What is the difference between the highest and the lowest Aid flow from UN agencies (US$) in Lebanon?
Make the answer very short. 7.60e+05. What is the difference between the highest and the lowest Aid flow from UN agencies (US$) in Pakistan?
Keep it short and to the point. 1.98e+06. What is the difference between the highest and the lowest Aid flow from UN agencies (US$) of Sao Tome and Principe?
Provide a short and direct response. 3.70e+05. 